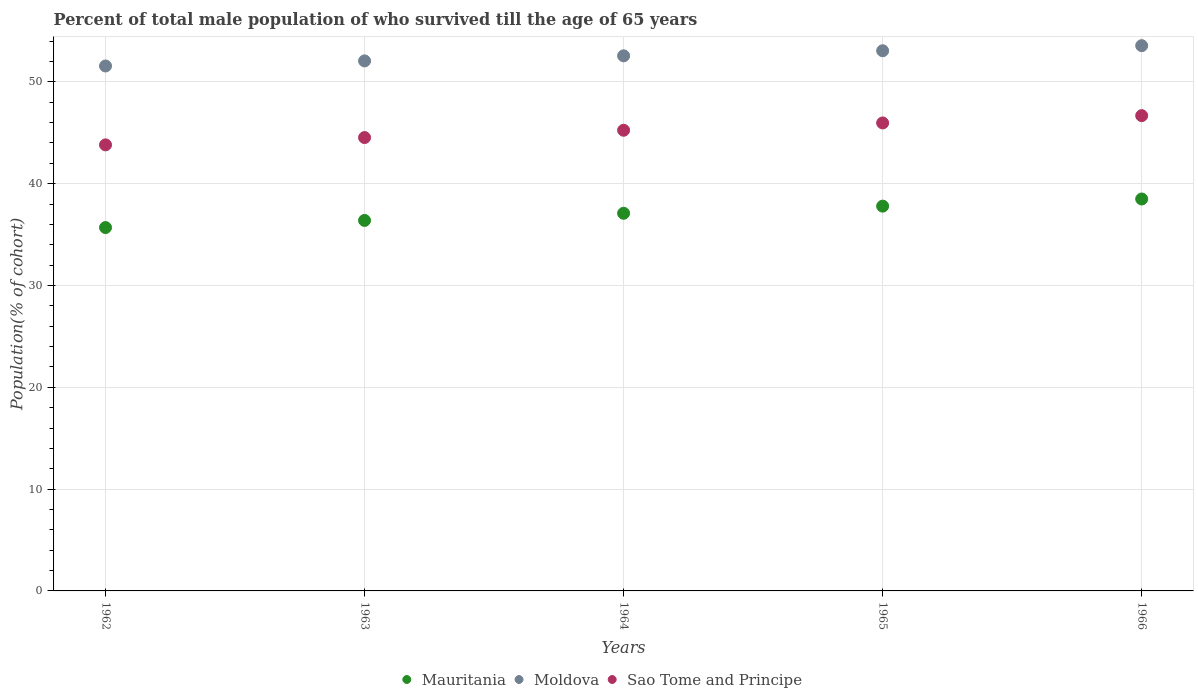How many different coloured dotlines are there?
Provide a succinct answer. 3. Is the number of dotlines equal to the number of legend labels?
Your response must be concise. Yes. What is the percentage of total male population who survived till the age of 65 years in Mauritania in 1965?
Give a very brief answer. 37.79. Across all years, what is the maximum percentage of total male population who survived till the age of 65 years in Moldova?
Provide a succinct answer. 53.55. Across all years, what is the minimum percentage of total male population who survived till the age of 65 years in Mauritania?
Provide a short and direct response. 35.69. In which year was the percentage of total male population who survived till the age of 65 years in Moldova maximum?
Your answer should be compact. 1966. What is the total percentage of total male population who survived till the age of 65 years in Mauritania in the graph?
Keep it short and to the point. 185.45. What is the difference between the percentage of total male population who survived till the age of 65 years in Sao Tome and Principe in 1963 and that in 1966?
Offer a very short reply. -2.15. What is the difference between the percentage of total male population who survived till the age of 65 years in Mauritania in 1962 and the percentage of total male population who survived till the age of 65 years in Sao Tome and Principe in 1965?
Your response must be concise. -10.27. What is the average percentage of total male population who survived till the age of 65 years in Sao Tome and Principe per year?
Provide a short and direct response. 45.24. In the year 1966, what is the difference between the percentage of total male population who survived till the age of 65 years in Moldova and percentage of total male population who survived till the age of 65 years in Mauritania?
Your response must be concise. 15.06. In how many years, is the percentage of total male population who survived till the age of 65 years in Sao Tome and Principe greater than 8 %?
Keep it short and to the point. 5. What is the ratio of the percentage of total male population who survived till the age of 65 years in Moldova in 1964 to that in 1966?
Offer a very short reply. 0.98. Is the percentage of total male population who survived till the age of 65 years in Mauritania in 1962 less than that in 1964?
Keep it short and to the point. Yes. Is the difference between the percentage of total male population who survived till the age of 65 years in Moldova in 1963 and 1964 greater than the difference between the percentage of total male population who survived till the age of 65 years in Mauritania in 1963 and 1964?
Make the answer very short. Yes. What is the difference between the highest and the second highest percentage of total male population who survived till the age of 65 years in Sao Tome and Principe?
Ensure brevity in your answer.  0.72. What is the difference between the highest and the lowest percentage of total male population who survived till the age of 65 years in Moldova?
Keep it short and to the point. 1.99. In how many years, is the percentage of total male population who survived till the age of 65 years in Sao Tome and Principe greater than the average percentage of total male population who survived till the age of 65 years in Sao Tome and Principe taken over all years?
Ensure brevity in your answer.  2. Is the sum of the percentage of total male population who survived till the age of 65 years in Moldova in 1965 and 1966 greater than the maximum percentage of total male population who survived till the age of 65 years in Mauritania across all years?
Keep it short and to the point. Yes. Does the percentage of total male population who survived till the age of 65 years in Mauritania monotonically increase over the years?
Offer a terse response. Yes. Is the percentage of total male population who survived till the age of 65 years in Mauritania strictly greater than the percentage of total male population who survived till the age of 65 years in Sao Tome and Principe over the years?
Give a very brief answer. No. Is the percentage of total male population who survived till the age of 65 years in Mauritania strictly less than the percentage of total male population who survived till the age of 65 years in Sao Tome and Principe over the years?
Provide a succinct answer. Yes. How many years are there in the graph?
Ensure brevity in your answer.  5. What is the difference between two consecutive major ticks on the Y-axis?
Your response must be concise. 10. Are the values on the major ticks of Y-axis written in scientific E-notation?
Provide a short and direct response. No. Does the graph contain any zero values?
Your answer should be compact. No. How many legend labels are there?
Provide a succinct answer. 3. How are the legend labels stacked?
Your response must be concise. Horizontal. What is the title of the graph?
Keep it short and to the point. Percent of total male population of who survived till the age of 65 years. Does "East Asia (all income levels)" appear as one of the legend labels in the graph?
Make the answer very short. No. What is the label or title of the X-axis?
Provide a succinct answer. Years. What is the label or title of the Y-axis?
Offer a terse response. Population(% of cohort). What is the Population(% of cohort) in Mauritania in 1962?
Provide a succinct answer. 35.69. What is the Population(% of cohort) of Moldova in 1962?
Give a very brief answer. 51.56. What is the Population(% of cohort) in Sao Tome and Principe in 1962?
Keep it short and to the point. 43.81. What is the Population(% of cohort) of Mauritania in 1963?
Ensure brevity in your answer.  36.39. What is the Population(% of cohort) in Moldova in 1963?
Make the answer very short. 52.06. What is the Population(% of cohort) of Sao Tome and Principe in 1963?
Offer a very short reply. 44.53. What is the Population(% of cohort) of Mauritania in 1964?
Your answer should be very brief. 37.09. What is the Population(% of cohort) of Moldova in 1964?
Ensure brevity in your answer.  52.55. What is the Population(% of cohort) of Sao Tome and Principe in 1964?
Make the answer very short. 45.24. What is the Population(% of cohort) in Mauritania in 1965?
Keep it short and to the point. 37.79. What is the Population(% of cohort) in Moldova in 1965?
Provide a short and direct response. 53.05. What is the Population(% of cohort) in Sao Tome and Principe in 1965?
Your response must be concise. 45.96. What is the Population(% of cohort) in Mauritania in 1966?
Ensure brevity in your answer.  38.49. What is the Population(% of cohort) of Moldova in 1966?
Make the answer very short. 53.55. What is the Population(% of cohort) in Sao Tome and Principe in 1966?
Give a very brief answer. 46.68. Across all years, what is the maximum Population(% of cohort) in Mauritania?
Ensure brevity in your answer.  38.49. Across all years, what is the maximum Population(% of cohort) of Moldova?
Provide a succinct answer. 53.55. Across all years, what is the maximum Population(% of cohort) of Sao Tome and Principe?
Make the answer very short. 46.68. Across all years, what is the minimum Population(% of cohort) in Mauritania?
Your response must be concise. 35.69. Across all years, what is the minimum Population(% of cohort) of Moldova?
Ensure brevity in your answer.  51.56. Across all years, what is the minimum Population(% of cohort) in Sao Tome and Principe?
Keep it short and to the point. 43.81. What is the total Population(% of cohort) in Mauritania in the graph?
Ensure brevity in your answer.  185.45. What is the total Population(% of cohort) in Moldova in the graph?
Offer a terse response. 262.77. What is the total Population(% of cohort) in Sao Tome and Principe in the graph?
Keep it short and to the point. 226.22. What is the difference between the Population(% of cohort) of Mauritania in 1962 and that in 1963?
Provide a succinct answer. -0.7. What is the difference between the Population(% of cohort) in Moldova in 1962 and that in 1963?
Your answer should be very brief. -0.5. What is the difference between the Population(% of cohort) of Sao Tome and Principe in 1962 and that in 1963?
Give a very brief answer. -0.72. What is the difference between the Population(% of cohort) of Mauritania in 1962 and that in 1964?
Offer a very short reply. -1.4. What is the difference between the Population(% of cohort) of Moldova in 1962 and that in 1964?
Keep it short and to the point. -1. What is the difference between the Population(% of cohort) of Sao Tome and Principe in 1962 and that in 1964?
Offer a terse response. -1.43. What is the difference between the Population(% of cohort) in Mauritania in 1962 and that in 1965?
Offer a terse response. -2.1. What is the difference between the Population(% of cohort) of Moldova in 1962 and that in 1965?
Your answer should be compact. -1.5. What is the difference between the Population(% of cohort) of Sao Tome and Principe in 1962 and that in 1965?
Ensure brevity in your answer.  -2.15. What is the difference between the Population(% of cohort) in Mauritania in 1962 and that in 1966?
Provide a succinct answer. -2.81. What is the difference between the Population(% of cohort) in Moldova in 1962 and that in 1966?
Provide a succinct answer. -1.99. What is the difference between the Population(% of cohort) in Sao Tome and Principe in 1962 and that in 1966?
Give a very brief answer. -2.87. What is the difference between the Population(% of cohort) of Mauritania in 1963 and that in 1964?
Offer a very short reply. -0.7. What is the difference between the Population(% of cohort) of Moldova in 1963 and that in 1964?
Keep it short and to the point. -0.5. What is the difference between the Population(% of cohort) of Sao Tome and Principe in 1963 and that in 1964?
Make the answer very short. -0.72. What is the difference between the Population(% of cohort) in Mauritania in 1963 and that in 1965?
Your answer should be very brief. -1.4. What is the difference between the Population(% of cohort) in Moldova in 1963 and that in 1965?
Offer a terse response. -1. What is the difference between the Population(% of cohort) of Sao Tome and Principe in 1963 and that in 1965?
Make the answer very short. -1.43. What is the difference between the Population(% of cohort) in Mauritania in 1963 and that in 1966?
Keep it short and to the point. -2.1. What is the difference between the Population(% of cohort) of Moldova in 1963 and that in 1966?
Your answer should be compact. -1.5. What is the difference between the Population(% of cohort) in Sao Tome and Principe in 1963 and that in 1966?
Provide a short and direct response. -2.15. What is the difference between the Population(% of cohort) in Mauritania in 1964 and that in 1965?
Your answer should be compact. -0.7. What is the difference between the Population(% of cohort) in Moldova in 1964 and that in 1965?
Your response must be concise. -0.5. What is the difference between the Population(% of cohort) in Sao Tome and Principe in 1964 and that in 1965?
Keep it short and to the point. -0.72. What is the difference between the Population(% of cohort) in Mauritania in 1964 and that in 1966?
Your answer should be very brief. -1.4. What is the difference between the Population(% of cohort) of Moldova in 1964 and that in 1966?
Give a very brief answer. -1. What is the difference between the Population(% of cohort) of Sao Tome and Principe in 1964 and that in 1966?
Make the answer very short. -1.43. What is the difference between the Population(% of cohort) of Mauritania in 1965 and that in 1966?
Your answer should be compact. -0.7. What is the difference between the Population(% of cohort) in Moldova in 1965 and that in 1966?
Your answer should be compact. -0.5. What is the difference between the Population(% of cohort) in Sao Tome and Principe in 1965 and that in 1966?
Keep it short and to the point. -0.72. What is the difference between the Population(% of cohort) of Mauritania in 1962 and the Population(% of cohort) of Moldova in 1963?
Keep it short and to the point. -16.37. What is the difference between the Population(% of cohort) in Mauritania in 1962 and the Population(% of cohort) in Sao Tome and Principe in 1963?
Keep it short and to the point. -8.84. What is the difference between the Population(% of cohort) in Moldova in 1962 and the Population(% of cohort) in Sao Tome and Principe in 1963?
Provide a succinct answer. 7.03. What is the difference between the Population(% of cohort) in Mauritania in 1962 and the Population(% of cohort) in Moldova in 1964?
Your answer should be very brief. -16.87. What is the difference between the Population(% of cohort) in Mauritania in 1962 and the Population(% of cohort) in Sao Tome and Principe in 1964?
Offer a very short reply. -9.56. What is the difference between the Population(% of cohort) of Moldova in 1962 and the Population(% of cohort) of Sao Tome and Principe in 1964?
Provide a short and direct response. 6.31. What is the difference between the Population(% of cohort) of Mauritania in 1962 and the Population(% of cohort) of Moldova in 1965?
Your response must be concise. -17.37. What is the difference between the Population(% of cohort) of Mauritania in 1962 and the Population(% of cohort) of Sao Tome and Principe in 1965?
Make the answer very short. -10.27. What is the difference between the Population(% of cohort) of Moldova in 1962 and the Population(% of cohort) of Sao Tome and Principe in 1965?
Offer a very short reply. 5.6. What is the difference between the Population(% of cohort) of Mauritania in 1962 and the Population(% of cohort) of Moldova in 1966?
Your response must be concise. -17.86. What is the difference between the Population(% of cohort) in Mauritania in 1962 and the Population(% of cohort) in Sao Tome and Principe in 1966?
Make the answer very short. -10.99. What is the difference between the Population(% of cohort) of Moldova in 1962 and the Population(% of cohort) of Sao Tome and Principe in 1966?
Make the answer very short. 4.88. What is the difference between the Population(% of cohort) in Mauritania in 1963 and the Population(% of cohort) in Moldova in 1964?
Your answer should be very brief. -16.17. What is the difference between the Population(% of cohort) of Mauritania in 1963 and the Population(% of cohort) of Sao Tome and Principe in 1964?
Your answer should be compact. -8.86. What is the difference between the Population(% of cohort) in Moldova in 1963 and the Population(% of cohort) in Sao Tome and Principe in 1964?
Make the answer very short. 6.81. What is the difference between the Population(% of cohort) in Mauritania in 1963 and the Population(% of cohort) in Moldova in 1965?
Your response must be concise. -16.66. What is the difference between the Population(% of cohort) of Mauritania in 1963 and the Population(% of cohort) of Sao Tome and Principe in 1965?
Your answer should be very brief. -9.57. What is the difference between the Population(% of cohort) of Moldova in 1963 and the Population(% of cohort) of Sao Tome and Principe in 1965?
Keep it short and to the point. 6.09. What is the difference between the Population(% of cohort) of Mauritania in 1963 and the Population(% of cohort) of Moldova in 1966?
Your response must be concise. -17.16. What is the difference between the Population(% of cohort) of Mauritania in 1963 and the Population(% of cohort) of Sao Tome and Principe in 1966?
Offer a terse response. -10.29. What is the difference between the Population(% of cohort) of Moldova in 1963 and the Population(% of cohort) of Sao Tome and Principe in 1966?
Offer a terse response. 5.38. What is the difference between the Population(% of cohort) in Mauritania in 1964 and the Population(% of cohort) in Moldova in 1965?
Give a very brief answer. -15.96. What is the difference between the Population(% of cohort) of Mauritania in 1964 and the Population(% of cohort) of Sao Tome and Principe in 1965?
Offer a very short reply. -8.87. What is the difference between the Population(% of cohort) in Moldova in 1964 and the Population(% of cohort) in Sao Tome and Principe in 1965?
Offer a terse response. 6.59. What is the difference between the Population(% of cohort) in Mauritania in 1964 and the Population(% of cohort) in Moldova in 1966?
Offer a very short reply. -16.46. What is the difference between the Population(% of cohort) in Mauritania in 1964 and the Population(% of cohort) in Sao Tome and Principe in 1966?
Keep it short and to the point. -9.59. What is the difference between the Population(% of cohort) of Moldova in 1964 and the Population(% of cohort) of Sao Tome and Principe in 1966?
Offer a very short reply. 5.88. What is the difference between the Population(% of cohort) in Mauritania in 1965 and the Population(% of cohort) in Moldova in 1966?
Offer a very short reply. -15.76. What is the difference between the Population(% of cohort) of Mauritania in 1965 and the Population(% of cohort) of Sao Tome and Principe in 1966?
Your answer should be compact. -8.89. What is the difference between the Population(% of cohort) in Moldova in 1965 and the Population(% of cohort) in Sao Tome and Principe in 1966?
Your answer should be very brief. 6.37. What is the average Population(% of cohort) of Mauritania per year?
Offer a terse response. 37.09. What is the average Population(% of cohort) in Moldova per year?
Offer a terse response. 52.55. What is the average Population(% of cohort) of Sao Tome and Principe per year?
Your answer should be very brief. 45.24. In the year 1962, what is the difference between the Population(% of cohort) in Mauritania and Population(% of cohort) in Moldova?
Provide a succinct answer. -15.87. In the year 1962, what is the difference between the Population(% of cohort) of Mauritania and Population(% of cohort) of Sao Tome and Principe?
Provide a short and direct response. -8.12. In the year 1962, what is the difference between the Population(% of cohort) in Moldova and Population(% of cohort) in Sao Tome and Principe?
Make the answer very short. 7.75. In the year 1963, what is the difference between the Population(% of cohort) of Mauritania and Population(% of cohort) of Moldova?
Keep it short and to the point. -15.67. In the year 1963, what is the difference between the Population(% of cohort) of Mauritania and Population(% of cohort) of Sao Tome and Principe?
Provide a short and direct response. -8.14. In the year 1963, what is the difference between the Population(% of cohort) in Moldova and Population(% of cohort) in Sao Tome and Principe?
Provide a succinct answer. 7.53. In the year 1964, what is the difference between the Population(% of cohort) in Mauritania and Population(% of cohort) in Moldova?
Your answer should be compact. -15.46. In the year 1964, what is the difference between the Population(% of cohort) of Mauritania and Population(% of cohort) of Sao Tome and Principe?
Make the answer very short. -8.15. In the year 1964, what is the difference between the Population(% of cohort) of Moldova and Population(% of cohort) of Sao Tome and Principe?
Provide a short and direct response. 7.31. In the year 1965, what is the difference between the Population(% of cohort) in Mauritania and Population(% of cohort) in Moldova?
Your answer should be compact. -15.26. In the year 1965, what is the difference between the Population(% of cohort) in Mauritania and Population(% of cohort) in Sao Tome and Principe?
Offer a very short reply. -8.17. In the year 1965, what is the difference between the Population(% of cohort) in Moldova and Population(% of cohort) in Sao Tome and Principe?
Provide a succinct answer. 7.09. In the year 1966, what is the difference between the Population(% of cohort) in Mauritania and Population(% of cohort) in Moldova?
Give a very brief answer. -15.06. In the year 1966, what is the difference between the Population(% of cohort) in Mauritania and Population(% of cohort) in Sao Tome and Principe?
Offer a very short reply. -8.19. In the year 1966, what is the difference between the Population(% of cohort) in Moldova and Population(% of cohort) in Sao Tome and Principe?
Ensure brevity in your answer.  6.87. What is the ratio of the Population(% of cohort) in Mauritania in 1962 to that in 1963?
Your answer should be very brief. 0.98. What is the ratio of the Population(% of cohort) of Sao Tome and Principe in 1962 to that in 1963?
Your answer should be very brief. 0.98. What is the ratio of the Population(% of cohort) in Mauritania in 1962 to that in 1964?
Keep it short and to the point. 0.96. What is the ratio of the Population(% of cohort) of Sao Tome and Principe in 1962 to that in 1964?
Ensure brevity in your answer.  0.97. What is the ratio of the Population(% of cohort) in Mauritania in 1962 to that in 1965?
Your answer should be compact. 0.94. What is the ratio of the Population(% of cohort) of Moldova in 1962 to that in 1965?
Your answer should be compact. 0.97. What is the ratio of the Population(% of cohort) of Sao Tome and Principe in 1962 to that in 1965?
Your answer should be compact. 0.95. What is the ratio of the Population(% of cohort) of Mauritania in 1962 to that in 1966?
Keep it short and to the point. 0.93. What is the ratio of the Population(% of cohort) in Moldova in 1962 to that in 1966?
Your response must be concise. 0.96. What is the ratio of the Population(% of cohort) of Sao Tome and Principe in 1962 to that in 1966?
Offer a very short reply. 0.94. What is the ratio of the Population(% of cohort) of Mauritania in 1963 to that in 1964?
Make the answer very short. 0.98. What is the ratio of the Population(% of cohort) in Sao Tome and Principe in 1963 to that in 1964?
Provide a succinct answer. 0.98. What is the ratio of the Population(% of cohort) in Mauritania in 1963 to that in 1965?
Your answer should be very brief. 0.96. What is the ratio of the Population(% of cohort) of Moldova in 1963 to that in 1965?
Offer a very short reply. 0.98. What is the ratio of the Population(% of cohort) of Sao Tome and Principe in 1963 to that in 1965?
Make the answer very short. 0.97. What is the ratio of the Population(% of cohort) of Mauritania in 1963 to that in 1966?
Your response must be concise. 0.95. What is the ratio of the Population(% of cohort) in Moldova in 1963 to that in 1966?
Make the answer very short. 0.97. What is the ratio of the Population(% of cohort) of Sao Tome and Principe in 1963 to that in 1966?
Ensure brevity in your answer.  0.95. What is the ratio of the Population(% of cohort) in Mauritania in 1964 to that in 1965?
Ensure brevity in your answer.  0.98. What is the ratio of the Population(% of cohort) of Moldova in 1964 to that in 1965?
Provide a short and direct response. 0.99. What is the ratio of the Population(% of cohort) in Sao Tome and Principe in 1964 to that in 1965?
Your answer should be compact. 0.98. What is the ratio of the Population(% of cohort) in Mauritania in 1964 to that in 1966?
Your response must be concise. 0.96. What is the ratio of the Population(% of cohort) of Moldova in 1964 to that in 1966?
Give a very brief answer. 0.98. What is the ratio of the Population(% of cohort) of Sao Tome and Principe in 1964 to that in 1966?
Provide a short and direct response. 0.97. What is the ratio of the Population(% of cohort) in Mauritania in 1965 to that in 1966?
Offer a terse response. 0.98. What is the ratio of the Population(% of cohort) of Sao Tome and Principe in 1965 to that in 1966?
Offer a very short reply. 0.98. What is the difference between the highest and the second highest Population(% of cohort) in Mauritania?
Provide a short and direct response. 0.7. What is the difference between the highest and the second highest Population(% of cohort) in Moldova?
Offer a very short reply. 0.5. What is the difference between the highest and the second highest Population(% of cohort) of Sao Tome and Principe?
Offer a very short reply. 0.72. What is the difference between the highest and the lowest Population(% of cohort) in Mauritania?
Make the answer very short. 2.81. What is the difference between the highest and the lowest Population(% of cohort) of Moldova?
Provide a succinct answer. 1.99. What is the difference between the highest and the lowest Population(% of cohort) in Sao Tome and Principe?
Ensure brevity in your answer.  2.87. 